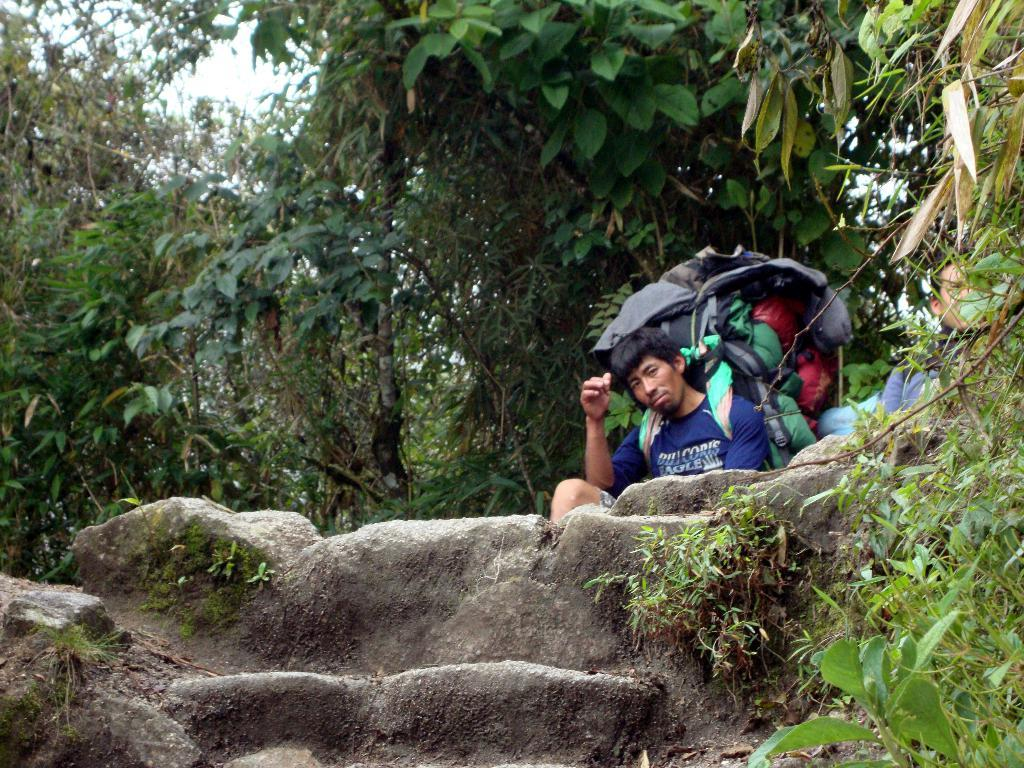What is present in the image? There is a man in the image. What is the man wearing? The man is wearing a bag. What can be seen in the background of the image? There are trees in the background of the image. What is the man's tendency to consume sugar in the image? There is no information about the man's sugar consumption or tendency in the image. 